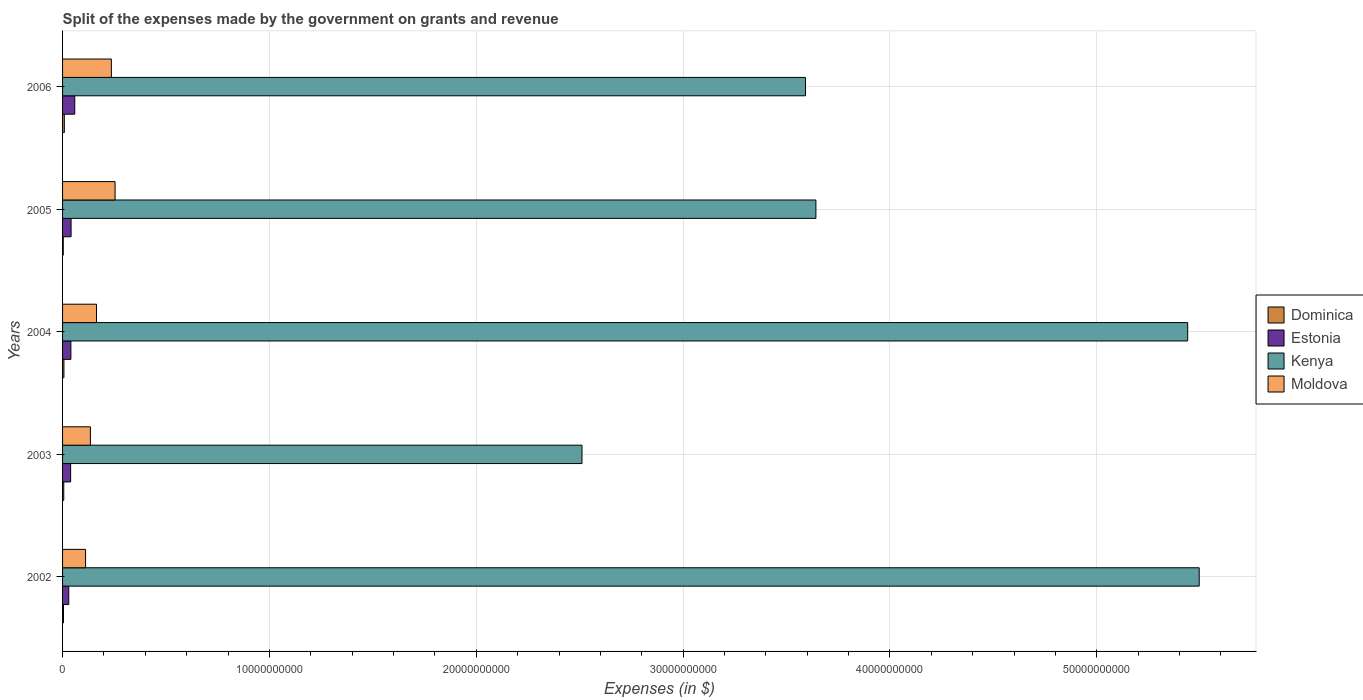How many different coloured bars are there?
Provide a succinct answer. 4. How many groups of bars are there?
Offer a very short reply. 5. Are the number of bars per tick equal to the number of legend labels?
Ensure brevity in your answer.  Yes. Are the number of bars on each tick of the Y-axis equal?
Keep it short and to the point. Yes. How many bars are there on the 5th tick from the bottom?
Give a very brief answer. 4. What is the label of the 4th group of bars from the top?
Your answer should be compact. 2003. What is the expenses made by the government on grants and revenue in Dominica in 2005?
Your answer should be compact. 3.38e+07. Across all years, what is the maximum expenses made by the government on grants and revenue in Dominica?
Give a very brief answer. 8.50e+07. Across all years, what is the minimum expenses made by the government on grants and revenue in Moldova?
Your response must be concise. 1.11e+09. In which year was the expenses made by the government on grants and revenue in Dominica minimum?
Your response must be concise. 2005. What is the total expenses made by the government on grants and revenue in Kenya in the graph?
Make the answer very short. 2.07e+11. What is the difference between the expenses made by the government on grants and revenue in Estonia in 2002 and that in 2003?
Make the answer very short. -9.10e+07. What is the difference between the expenses made by the government on grants and revenue in Kenya in 2004 and the expenses made by the government on grants and revenue in Dominica in 2002?
Your response must be concise. 5.43e+1. What is the average expenses made by the government on grants and revenue in Kenya per year?
Your answer should be very brief. 4.14e+1. In the year 2006, what is the difference between the expenses made by the government on grants and revenue in Moldova and expenses made by the government on grants and revenue in Kenya?
Make the answer very short. -3.36e+1. What is the ratio of the expenses made by the government on grants and revenue in Kenya in 2004 to that in 2005?
Provide a succinct answer. 1.49. Is the expenses made by the government on grants and revenue in Estonia in 2002 less than that in 2003?
Your answer should be compact. Yes. What is the difference between the highest and the second highest expenses made by the government on grants and revenue in Kenya?
Your answer should be compact. 5.57e+08. What is the difference between the highest and the lowest expenses made by the government on grants and revenue in Dominica?
Offer a very short reply. 5.12e+07. In how many years, is the expenses made by the government on grants and revenue in Moldova greater than the average expenses made by the government on grants and revenue in Moldova taken over all years?
Offer a terse response. 2. What does the 2nd bar from the top in 2004 represents?
Your response must be concise. Kenya. What does the 2nd bar from the bottom in 2005 represents?
Your answer should be very brief. Estonia. How many years are there in the graph?
Offer a very short reply. 5. Does the graph contain any zero values?
Provide a short and direct response. No. How many legend labels are there?
Your answer should be very brief. 4. What is the title of the graph?
Your response must be concise. Split of the expenses made by the government on grants and revenue. What is the label or title of the X-axis?
Offer a terse response. Expenses (in $). What is the label or title of the Y-axis?
Your answer should be compact. Years. What is the Expenses (in $) in Dominica in 2002?
Offer a terse response. 4.49e+07. What is the Expenses (in $) of Estonia in 2002?
Your answer should be very brief. 2.99e+08. What is the Expenses (in $) of Kenya in 2002?
Offer a terse response. 5.49e+1. What is the Expenses (in $) in Moldova in 2002?
Provide a short and direct response. 1.11e+09. What is the Expenses (in $) of Dominica in 2003?
Give a very brief answer. 5.81e+07. What is the Expenses (in $) of Estonia in 2003?
Your answer should be very brief. 3.90e+08. What is the Expenses (in $) of Kenya in 2003?
Keep it short and to the point. 2.51e+1. What is the Expenses (in $) of Moldova in 2003?
Your response must be concise. 1.35e+09. What is the Expenses (in $) of Dominica in 2004?
Provide a short and direct response. 6.56e+07. What is the Expenses (in $) in Estonia in 2004?
Your response must be concise. 4.03e+08. What is the Expenses (in $) in Kenya in 2004?
Offer a very short reply. 5.44e+1. What is the Expenses (in $) of Moldova in 2004?
Make the answer very short. 1.64e+09. What is the Expenses (in $) of Dominica in 2005?
Provide a short and direct response. 3.38e+07. What is the Expenses (in $) in Estonia in 2005?
Keep it short and to the point. 4.11e+08. What is the Expenses (in $) in Kenya in 2005?
Your answer should be compact. 3.64e+1. What is the Expenses (in $) in Moldova in 2005?
Your answer should be compact. 2.54e+09. What is the Expenses (in $) in Dominica in 2006?
Your answer should be very brief. 8.50e+07. What is the Expenses (in $) of Estonia in 2006?
Make the answer very short. 5.90e+08. What is the Expenses (in $) of Kenya in 2006?
Your answer should be very brief. 3.59e+1. What is the Expenses (in $) in Moldova in 2006?
Provide a succinct answer. 2.36e+09. Across all years, what is the maximum Expenses (in $) in Dominica?
Your response must be concise. 8.50e+07. Across all years, what is the maximum Expenses (in $) of Estonia?
Your answer should be compact. 5.90e+08. Across all years, what is the maximum Expenses (in $) in Kenya?
Your response must be concise. 5.49e+1. Across all years, what is the maximum Expenses (in $) in Moldova?
Provide a succinct answer. 2.54e+09. Across all years, what is the minimum Expenses (in $) of Dominica?
Make the answer very short. 3.38e+07. Across all years, what is the minimum Expenses (in $) of Estonia?
Provide a succinct answer. 2.99e+08. Across all years, what is the minimum Expenses (in $) in Kenya?
Offer a terse response. 2.51e+1. Across all years, what is the minimum Expenses (in $) in Moldova?
Give a very brief answer. 1.11e+09. What is the total Expenses (in $) of Dominica in the graph?
Provide a short and direct response. 2.87e+08. What is the total Expenses (in $) in Estonia in the graph?
Provide a short and direct response. 2.09e+09. What is the total Expenses (in $) of Kenya in the graph?
Keep it short and to the point. 2.07e+11. What is the total Expenses (in $) of Moldova in the graph?
Offer a terse response. 9.00e+09. What is the difference between the Expenses (in $) of Dominica in 2002 and that in 2003?
Keep it short and to the point. -1.32e+07. What is the difference between the Expenses (in $) in Estonia in 2002 and that in 2003?
Offer a very short reply. -9.10e+07. What is the difference between the Expenses (in $) of Kenya in 2002 and that in 2003?
Make the answer very short. 2.98e+1. What is the difference between the Expenses (in $) of Moldova in 2002 and that in 2003?
Keep it short and to the point. -2.33e+08. What is the difference between the Expenses (in $) of Dominica in 2002 and that in 2004?
Your answer should be compact. -2.07e+07. What is the difference between the Expenses (in $) in Estonia in 2002 and that in 2004?
Your answer should be compact. -1.04e+08. What is the difference between the Expenses (in $) of Kenya in 2002 and that in 2004?
Your answer should be compact. 5.57e+08. What is the difference between the Expenses (in $) in Moldova in 2002 and that in 2004?
Make the answer very short. -5.26e+08. What is the difference between the Expenses (in $) in Dominica in 2002 and that in 2005?
Offer a very short reply. 1.11e+07. What is the difference between the Expenses (in $) in Estonia in 2002 and that in 2005?
Offer a terse response. -1.12e+08. What is the difference between the Expenses (in $) in Kenya in 2002 and that in 2005?
Keep it short and to the point. 1.85e+1. What is the difference between the Expenses (in $) of Moldova in 2002 and that in 2005?
Keep it short and to the point. -1.43e+09. What is the difference between the Expenses (in $) in Dominica in 2002 and that in 2006?
Your response must be concise. -4.01e+07. What is the difference between the Expenses (in $) in Estonia in 2002 and that in 2006?
Ensure brevity in your answer.  -2.91e+08. What is the difference between the Expenses (in $) of Kenya in 2002 and that in 2006?
Offer a terse response. 1.90e+1. What is the difference between the Expenses (in $) in Moldova in 2002 and that in 2006?
Your answer should be very brief. -1.25e+09. What is the difference between the Expenses (in $) of Dominica in 2003 and that in 2004?
Make the answer very short. -7.50e+06. What is the difference between the Expenses (in $) of Estonia in 2003 and that in 2004?
Provide a short and direct response. -1.28e+07. What is the difference between the Expenses (in $) of Kenya in 2003 and that in 2004?
Make the answer very short. -2.93e+1. What is the difference between the Expenses (in $) in Moldova in 2003 and that in 2004?
Give a very brief answer. -2.94e+08. What is the difference between the Expenses (in $) of Dominica in 2003 and that in 2005?
Give a very brief answer. 2.43e+07. What is the difference between the Expenses (in $) in Estonia in 2003 and that in 2005?
Offer a terse response. -2.12e+07. What is the difference between the Expenses (in $) of Kenya in 2003 and that in 2005?
Offer a very short reply. -1.13e+1. What is the difference between the Expenses (in $) in Moldova in 2003 and that in 2005?
Offer a terse response. -1.19e+09. What is the difference between the Expenses (in $) in Dominica in 2003 and that in 2006?
Provide a succinct answer. -2.69e+07. What is the difference between the Expenses (in $) of Estonia in 2003 and that in 2006?
Give a very brief answer. -2.00e+08. What is the difference between the Expenses (in $) of Kenya in 2003 and that in 2006?
Provide a succinct answer. -1.08e+1. What is the difference between the Expenses (in $) of Moldova in 2003 and that in 2006?
Ensure brevity in your answer.  -1.01e+09. What is the difference between the Expenses (in $) of Dominica in 2004 and that in 2005?
Your answer should be very brief. 3.18e+07. What is the difference between the Expenses (in $) in Estonia in 2004 and that in 2005?
Ensure brevity in your answer.  -8.40e+06. What is the difference between the Expenses (in $) of Kenya in 2004 and that in 2005?
Your response must be concise. 1.80e+1. What is the difference between the Expenses (in $) of Moldova in 2004 and that in 2005?
Offer a very short reply. -9.00e+08. What is the difference between the Expenses (in $) in Dominica in 2004 and that in 2006?
Give a very brief answer. -1.94e+07. What is the difference between the Expenses (in $) in Estonia in 2004 and that in 2006?
Your response must be concise. -1.87e+08. What is the difference between the Expenses (in $) in Kenya in 2004 and that in 2006?
Your answer should be compact. 1.85e+1. What is the difference between the Expenses (in $) in Moldova in 2004 and that in 2006?
Offer a terse response. -7.19e+08. What is the difference between the Expenses (in $) in Dominica in 2005 and that in 2006?
Offer a very short reply. -5.12e+07. What is the difference between the Expenses (in $) in Estonia in 2005 and that in 2006?
Your answer should be compact. -1.79e+08. What is the difference between the Expenses (in $) in Kenya in 2005 and that in 2006?
Offer a terse response. 5.04e+08. What is the difference between the Expenses (in $) in Moldova in 2005 and that in 2006?
Make the answer very short. 1.80e+08. What is the difference between the Expenses (in $) in Dominica in 2002 and the Expenses (in $) in Estonia in 2003?
Offer a very short reply. -3.45e+08. What is the difference between the Expenses (in $) in Dominica in 2002 and the Expenses (in $) in Kenya in 2003?
Keep it short and to the point. -2.51e+1. What is the difference between the Expenses (in $) of Dominica in 2002 and the Expenses (in $) of Moldova in 2003?
Give a very brief answer. -1.30e+09. What is the difference between the Expenses (in $) of Estonia in 2002 and the Expenses (in $) of Kenya in 2003?
Make the answer very short. -2.48e+1. What is the difference between the Expenses (in $) of Estonia in 2002 and the Expenses (in $) of Moldova in 2003?
Ensure brevity in your answer.  -1.05e+09. What is the difference between the Expenses (in $) in Kenya in 2002 and the Expenses (in $) in Moldova in 2003?
Your answer should be very brief. 5.36e+1. What is the difference between the Expenses (in $) in Dominica in 2002 and the Expenses (in $) in Estonia in 2004?
Provide a succinct answer. -3.58e+08. What is the difference between the Expenses (in $) in Dominica in 2002 and the Expenses (in $) in Kenya in 2004?
Provide a succinct answer. -5.43e+1. What is the difference between the Expenses (in $) in Dominica in 2002 and the Expenses (in $) in Moldova in 2004?
Your answer should be compact. -1.59e+09. What is the difference between the Expenses (in $) in Estonia in 2002 and the Expenses (in $) in Kenya in 2004?
Provide a succinct answer. -5.41e+1. What is the difference between the Expenses (in $) of Estonia in 2002 and the Expenses (in $) of Moldova in 2004?
Provide a succinct answer. -1.34e+09. What is the difference between the Expenses (in $) in Kenya in 2002 and the Expenses (in $) in Moldova in 2004?
Keep it short and to the point. 5.33e+1. What is the difference between the Expenses (in $) in Dominica in 2002 and the Expenses (in $) in Estonia in 2005?
Your answer should be very brief. -3.66e+08. What is the difference between the Expenses (in $) of Dominica in 2002 and the Expenses (in $) of Kenya in 2005?
Provide a short and direct response. -3.64e+1. What is the difference between the Expenses (in $) in Dominica in 2002 and the Expenses (in $) in Moldova in 2005?
Offer a very short reply. -2.49e+09. What is the difference between the Expenses (in $) in Estonia in 2002 and the Expenses (in $) in Kenya in 2005?
Make the answer very short. -3.61e+1. What is the difference between the Expenses (in $) of Estonia in 2002 and the Expenses (in $) of Moldova in 2005?
Keep it short and to the point. -2.24e+09. What is the difference between the Expenses (in $) of Kenya in 2002 and the Expenses (in $) of Moldova in 2005?
Offer a very short reply. 5.24e+1. What is the difference between the Expenses (in $) of Dominica in 2002 and the Expenses (in $) of Estonia in 2006?
Offer a terse response. -5.45e+08. What is the difference between the Expenses (in $) of Dominica in 2002 and the Expenses (in $) of Kenya in 2006?
Offer a terse response. -3.59e+1. What is the difference between the Expenses (in $) in Dominica in 2002 and the Expenses (in $) in Moldova in 2006?
Your answer should be compact. -2.31e+09. What is the difference between the Expenses (in $) in Estonia in 2002 and the Expenses (in $) in Kenya in 2006?
Your answer should be compact. -3.56e+1. What is the difference between the Expenses (in $) in Estonia in 2002 and the Expenses (in $) in Moldova in 2006?
Offer a terse response. -2.06e+09. What is the difference between the Expenses (in $) of Kenya in 2002 and the Expenses (in $) of Moldova in 2006?
Your response must be concise. 5.26e+1. What is the difference between the Expenses (in $) in Dominica in 2003 and the Expenses (in $) in Estonia in 2004?
Offer a very short reply. -3.45e+08. What is the difference between the Expenses (in $) of Dominica in 2003 and the Expenses (in $) of Kenya in 2004?
Keep it short and to the point. -5.43e+1. What is the difference between the Expenses (in $) in Dominica in 2003 and the Expenses (in $) in Moldova in 2004?
Give a very brief answer. -1.58e+09. What is the difference between the Expenses (in $) in Estonia in 2003 and the Expenses (in $) in Kenya in 2004?
Offer a very short reply. -5.40e+1. What is the difference between the Expenses (in $) of Estonia in 2003 and the Expenses (in $) of Moldova in 2004?
Provide a succinct answer. -1.25e+09. What is the difference between the Expenses (in $) of Kenya in 2003 and the Expenses (in $) of Moldova in 2004?
Give a very brief answer. 2.35e+1. What is the difference between the Expenses (in $) in Dominica in 2003 and the Expenses (in $) in Estonia in 2005?
Make the answer very short. -3.53e+08. What is the difference between the Expenses (in $) in Dominica in 2003 and the Expenses (in $) in Kenya in 2005?
Your answer should be compact. -3.64e+1. What is the difference between the Expenses (in $) of Dominica in 2003 and the Expenses (in $) of Moldova in 2005?
Your answer should be compact. -2.48e+09. What is the difference between the Expenses (in $) in Estonia in 2003 and the Expenses (in $) in Kenya in 2005?
Make the answer very short. -3.60e+1. What is the difference between the Expenses (in $) of Estonia in 2003 and the Expenses (in $) of Moldova in 2005?
Keep it short and to the point. -2.15e+09. What is the difference between the Expenses (in $) of Kenya in 2003 and the Expenses (in $) of Moldova in 2005?
Ensure brevity in your answer.  2.26e+1. What is the difference between the Expenses (in $) in Dominica in 2003 and the Expenses (in $) in Estonia in 2006?
Ensure brevity in your answer.  -5.32e+08. What is the difference between the Expenses (in $) of Dominica in 2003 and the Expenses (in $) of Kenya in 2006?
Your answer should be very brief. -3.59e+1. What is the difference between the Expenses (in $) in Dominica in 2003 and the Expenses (in $) in Moldova in 2006?
Your answer should be very brief. -2.30e+09. What is the difference between the Expenses (in $) of Estonia in 2003 and the Expenses (in $) of Kenya in 2006?
Give a very brief answer. -3.55e+1. What is the difference between the Expenses (in $) of Estonia in 2003 and the Expenses (in $) of Moldova in 2006?
Provide a short and direct response. -1.97e+09. What is the difference between the Expenses (in $) in Kenya in 2003 and the Expenses (in $) in Moldova in 2006?
Make the answer very short. 2.28e+1. What is the difference between the Expenses (in $) in Dominica in 2004 and the Expenses (in $) in Estonia in 2005?
Your answer should be compact. -3.46e+08. What is the difference between the Expenses (in $) in Dominica in 2004 and the Expenses (in $) in Kenya in 2005?
Offer a terse response. -3.64e+1. What is the difference between the Expenses (in $) in Dominica in 2004 and the Expenses (in $) in Moldova in 2005?
Your answer should be compact. -2.47e+09. What is the difference between the Expenses (in $) in Estonia in 2004 and the Expenses (in $) in Kenya in 2005?
Make the answer very short. -3.60e+1. What is the difference between the Expenses (in $) in Estonia in 2004 and the Expenses (in $) in Moldova in 2005?
Make the answer very short. -2.14e+09. What is the difference between the Expenses (in $) of Kenya in 2004 and the Expenses (in $) of Moldova in 2005?
Make the answer very short. 5.19e+1. What is the difference between the Expenses (in $) of Dominica in 2004 and the Expenses (in $) of Estonia in 2006?
Ensure brevity in your answer.  -5.24e+08. What is the difference between the Expenses (in $) in Dominica in 2004 and the Expenses (in $) in Kenya in 2006?
Your answer should be very brief. -3.58e+1. What is the difference between the Expenses (in $) in Dominica in 2004 and the Expenses (in $) in Moldova in 2006?
Ensure brevity in your answer.  -2.29e+09. What is the difference between the Expenses (in $) of Estonia in 2004 and the Expenses (in $) of Kenya in 2006?
Provide a short and direct response. -3.55e+1. What is the difference between the Expenses (in $) in Estonia in 2004 and the Expenses (in $) in Moldova in 2006?
Your answer should be very brief. -1.96e+09. What is the difference between the Expenses (in $) in Kenya in 2004 and the Expenses (in $) in Moldova in 2006?
Ensure brevity in your answer.  5.20e+1. What is the difference between the Expenses (in $) in Dominica in 2005 and the Expenses (in $) in Estonia in 2006?
Keep it short and to the point. -5.56e+08. What is the difference between the Expenses (in $) in Dominica in 2005 and the Expenses (in $) in Kenya in 2006?
Provide a succinct answer. -3.59e+1. What is the difference between the Expenses (in $) in Dominica in 2005 and the Expenses (in $) in Moldova in 2006?
Your answer should be very brief. -2.32e+09. What is the difference between the Expenses (in $) in Estonia in 2005 and the Expenses (in $) in Kenya in 2006?
Your answer should be very brief. -3.55e+1. What is the difference between the Expenses (in $) in Estonia in 2005 and the Expenses (in $) in Moldova in 2006?
Keep it short and to the point. -1.95e+09. What is the difference between the Expenses (in $) in Kenya in 2005 and the Expenses (in $) in Moldova in 2006?
Ensure brevity in your answer.  3.41e+1. What is the average Expenses (in $) in Dominica per year?
Your answer should be very brief. 5.75e+07. What is the average Expenses (in $) in Estonia per year?
Your answer should be very brief. 4.19e+08. What is the average Expenses (in $) in Kenya per year?
Keep it short and to the point. 4.14e+1. What is the average Expenses (in $) of Moldova per year?
Provide a succinct answer. 1.80e+09. In the year 2002, what is the difference between the Expenses (in $) of Dominica and Expenses (in $) of Estonia?
Your response must be concise. -2.54e+08. In the year 2002, what is the difference between the Expenses (in $) of Dominica and Expenses (in $) of Kenya?
Your response must be concise. -5.49e+1. In the year 2002, what is the difference between the Expenses (in $) in Dominica and Expenses (in $) in Moldova?
Provide a succinct answer. -1.07e+09. In the year 2002, what is the difference between the Expenses (in $) of Estonia and Expenses (in $) of Kenya?
Your answer should be compact. -5.46e+1. In the year 2002, what is the difference between the Expenses (in $) in Estonia and Expenses (in $) in Moldova?
Your response must be concise. -8.14e+08. In the year 2002, what is the difference between the Expenses (in $) of Kenya and Expenses (in $) of Moldova?
Your response must be concise. 5.38e+1. In the year 2003, what is the difference between the Expenses (in $) in Dominica and Expenses (in $) in Estonia?
Give a very brief answer. -3.32e+08. In the year 2003, what is the difference between the Expenses (in $) in Dominica and Expenses (in $) in Kenya?
Provide a short and direct response. -2.51e+1. In the year 2003, what is the difference between the Expenses (in $) of Dominica and Expenses (in $) of Moldova?
Offer a very short reply. -1.29e+09. In the year 2003, what is the difference between the Expenses (in $) of Estonia and Expenses (in $) of Kenya?
Give a very brief answer. -2.47e+1. In the year 2003, what is the difference between the Expenses (in $) of Estonia and Expenses (in $) of Moldova?
Provide a succinct answer. -9.56e+08. In the year 2003, what is the difference between the Expenses (in $) in Kenya and Expenses (in $) in Moldova?
Ensure brevity in your answer.  2.38e+1. In the year 2004, what is the difference between the Expenses (in $) of Dominica and Expenses (in $) of Estonia?
Your answer should be compact. -3.37e+08. In the year 2004, what is the difference between the Expenses (in $) of Dominica and Expenses (in $) of Kenya?
Your response must be concise. -5.43e+1. In the year 2004, what is the difference between the Expenses (in $) in Dominica and Expenses (in $) in Moldova?
Give a very brief answer. -1.57e+09. In the year 2004, what is the difference between the Expenses (in $) of Estonia and Expenses (in $) of Kenya?
Keep it short and to the point. -5.40e+1. In the year 2004, what is the difference between the Expenses (in $) in Estonia and Expenses (in $) in Moldova?
Provide a short and direct response. -1.24e+09. In the year 2004, what is the difference between the Expenses (in $) of Kenya and Expenses (in $) of Moldova?
Your answer should be compact. 5.28e+1. In the year 2005, what is the difference between the Expenses (in $) in Dominica and Expenses (in $) in Estonia?
Provide a short and direct response. -3.77e+08. In the year 2005, what is the difference between the Expenses (in $) of Dominica and Expenses (in $) of Kenya?
Make the answer very short. -3.64e+1. In the year 2005, what is the difference between the Expenses (in $) in Dominica and Expenses (in $) in Moldova?
Keep it short and to the point. -2.51e+09. In the year 2005, what is the difference between the Expenses (in $) of Estonia and Expenses (in $) of Kenya?
Offer a very short reply. -3.60e+1. In the year 2005, what is the difference between the Expenses (in $) in Estonia and Expenses (in $) in Moldova?
Offer a terse response. -2.13e+09. In the year 2005, what is the difference between the Expenses (in $) of Kenya and Expenses (in $) of Moldova?
Offer a terse response. 3.39e+1. In the year 2006, what is the difference between the Expenses (in $) in Dominica and Expenses (in $) in Estonia?
Provide a succinct answer. -5.05e+08. In the year 2006, what is the difference between the Expenses (in $) in Dominica and Expenses (in $) in Kenya?
Provide a succinct answer. -3.58e+1. In the year 2006, what is the difference between the Expenses (in $) in Dominica and Expenses (in $) in Moldova?
Your response must be concise. -2.27e+09. In the year 2006, what is the difference between the Expenses (in $) in Estonia and Expenses (in $) in Kenya?
Make the answer very short. -3.53e+1. In the year 2006, what is the difference between the Expenses (in $) of Estonia and Expenses (in $) of Moldova?
Your response must be concise. -1.77e+09. In the year 2006, what is the difference between the Expenses (in $) of Kenya and Expenses (in $) of Moldova?
Make the answer very short. 3.36e+1. What is the ratio of the Expenses (in $) in Dominica in 2002 to that in 2003?
Keep it short and to the point. 0.77. What is the ratio of the Expenses (in $) in Estonia in 2002 to that in 2003?
Your response must be concise. 0.77. What is the ratio of the Expenses (in $) in Kenya in 2002 to that in 2003?
Provide a short and direct response. 2.19. What is the ratio of the Expenses (in $) in Moldova in 2002 to that in 2003?
Provide a succinct answer. 0.83. What is the ratio of the Expenses (in $) in Dominica in 2002 to that in 2004?
Ensure brevity in your answer.  0.68. What is the ratio of the Expenses (in $) in Estonia in 2002 to that in 2004?
Provide a short and direct response. 0.74. What is the ratio of the Expenses (in $) in Kenya in 2002 to that in 2004?
Keep it short and to the point. 1.01. What is the ratio of the Expenses (in $) of Moldova in 2002 to that in 2004?
Provide a succinct answer. 0.68. What is the ratio of the Expenses (in $) of Dominica in 2002 to that in 2005?
Offer a terse response. 1.33. What is the ratio of the Expenses (in $) in Estonia in 2002 to that in 2005?
Ensure brevity in your answer.  0.73. What is the ratio of the Expenses (in $) of Kenya in 2002 to that in 2005?
Offer a terse response. 1.51. What is the ratio of the Expenses (in $) in Moldova in 2002 to that in 2005?
Make the answer very short. 0.44. What is the ratio of the Expenses (in $) in Dominica in 2002 to that in 2006?
Provide a short and direct response. 0.53. What is the ratio of the Expenses (in $) in Estonia in 2002 to that in 2006?
Make the answer very short. 0.51. What is the ratio of the Expenses (in $) of Kenya in 2002 to that in 2006?
Give a very brief answer. 1.53. What is the ratio of the Expenses (in $) of Moldova in 2002 to that in 2006?
Ensure brevity in your answer.  0.47. What is the ratio of the Expenses (in $) of Dominica in 2003 to that in 2004?
Your answer should be compact. 0.89. What is the ratio of the Expenses (in $) in Estonia in 2003 to that in 2004?
Keep it short and to the point. 0.97. What is the ratio of the Expenses (in $) in Kenya in 2003 to that in 2004?
Give a very brief answer. 0.46. What is the ratio of the Expenses (in $) of Moldova in 2003 to that in 2004?
Keep it short and to the point. 0.82. What is the ratio of the Expenses (in $) of Dominica in 2003 to that in 2005?
Your answer should be very brief. 1.72. What is the ratio of the Expenses (in $) in Estonia in 2003 to that in 2005?
Your answer should be very brief. 0.95. What is the ratio of the Expenses (in $) of Kenya in 2003 to that in 2005?
Offer a very short reply. 0.69. What is the ratio of the Expenses (in $) in Moldova in 2003 to that in 2005?
Your response must be concise. 0.53. What is the ratio of the Expenses (in $) in Dominica in 2003 to that in 2006?
Your response must be concise. 0.68. What is the ratio of the Expenses (in $) of Estonia in 2003 to that in 2006?
Ensure brevity in your answer.  0.66. What is the ratio of the Expenses (in $) of Kenya in 2003 to that in 2006?
Provide a succinct answer. 0.7. What is the ratio of the Expenses (in $) of Moldova in 2003 to that in 2006?
Give a very brief answer. 0.57. What is the ratio of the Expenses (in $) of Dominica in 2004 to that in 2005?
Ensure brevity in your answer.  1.94. What is the ratio of the Expenses (in $) of Estonia in 2004 to that in 2005?
Your answer should be very brief. 0.98. What is the ratio of the Expenses (in $) of Kenya in 2004 to that in 2005?
Your answer should be very brief. 1.49. What is the ratio of the Expenses (in $) of Moldova in 2004 to that in 2005?
Make the answer very short. 0.65. What is the ratio of the Expenses (in $) in Dominica in 2004 to that in 2006?
Keep it short and to the point. 0.77. What is the ratio of the Expenses (in $) in Estonia in 2004 to that in 2006?
Keep it short and to the point. 0.68. What is the ratio of the Expenses (in $) of Kenya in 2004 to that in 2006?
Your response must be concise. 1.51. What is the ratio of the Expenses (in $) of Moldova in 2004 to that in 2006?
Your response must be concise. 0.7. What is the ratio of the Expenses (in $) of Dominica in 2005 to that in 2006?
Keep it short and to the point. 0.4. What is the ratio of the Expenses (in $) of Estonia in 2005 to that in 2006?
Provide a short and direct response. 0.7. What is the ratio of the Expenses (in $) in Kenya in 2005 to that in 2006?
Keep it short and to the point. 1.01. What is the ratio of the Expenses (in $) of Moldova in 2005 to that in 2006?
Your answer should be very brief. 1.08. What is the difference between the highest and the second highest Expenses (in $) in Dominica?
Ensure brevity in your answer.  1.94e+07. What is the difference between the highest and the second highest Expenses (in $) in Estonia?
Provide a succinct answer. 1.79e+08. What is the difference between the highest and the second highest Expenses (in $) in Kenya?
Your answer should be compact. 5.57e+08. What is the difference between the highest and the second highest Expenses (in $) of Moldova?
Ensure brevity in your answer.  1.80e+08. What is the difference between the highest and the lowest Expenses (in $) of Dominica?
Make the answer very short. 5.12e+07. What is the difference between the highest and the lowest Expenses (in $) of Estonia?
Ensure brevity in your answer.  2.91e+08. What is the difference between the highest and the lowest Expenses (in $) in Kenya?
Provide a succinct answer. 2.98e+1. What is the difference between the highest and the lowest Expenses (in $) in Moldova?
Make the answer very short. 1.43e+09. 